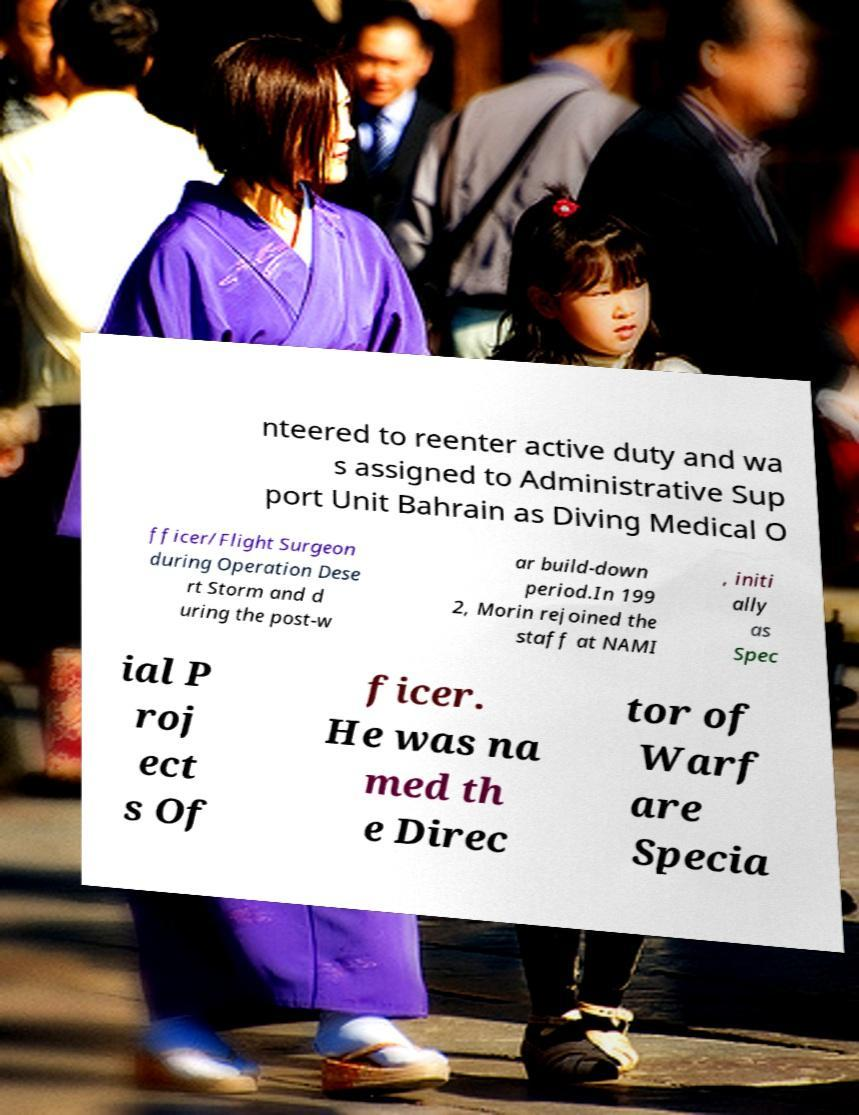For documentation purposes, I need the text within this image transcribed. Could you provide that? nteered to reenter active duty and wa s assigned to Administrative Sup port Unit Bahrain as Diving Medical O fficer/Flight Surgeon during Operation Dese rt Storm and d uring the post-w ar build-down period.In 199 2, Morin rejoined the staff at NAMI , initi ally as Spec ial P roj ect s Of ficer. He was na med th e Direc tor of Warf are Specia 